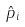Convert formula to latex. <formula><loc_0><loc_0><loc_500><loc_500>\hat { p } _ { i }</formula> 